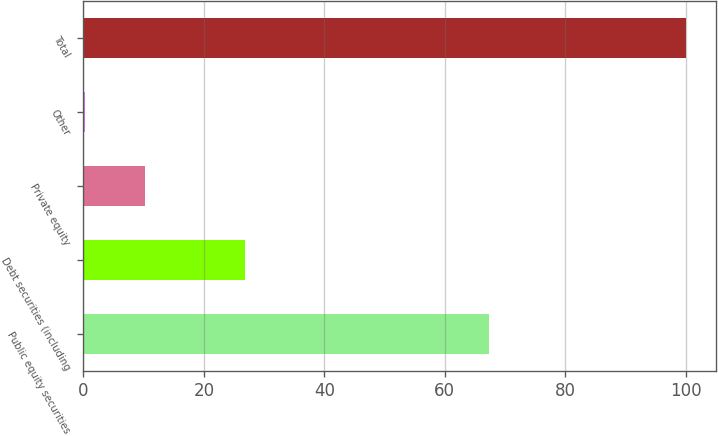Convert chart to OTSL. <chart><loc_0><loc_0><loc_500><loc_500><bar_chart><fcel>Public equity securities<fcel>Debt securities (including<fcel>Private equity<fcel>Other<fcel>Total<nl><fcel>67.3<fcel>26.8<fcel>10.27<fcel>0.3<fcel>100<nl></chart> 